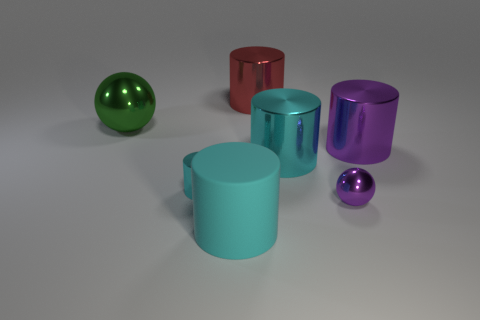Are any large yellow metal blocks visible?
Provide a succinct answer. No. Are there any large cylinders made of the same material as the green object?
Provide a succinct answer. Yes. Is there any other thing that has the same material as the tiny cyan object?
Ensure brevity in your answer.  Yes. What is the color of the tiny ball?
Your answer should be compact. Purple. What is the shape of the other big object that is the same color as the big rubber thing?
Provide a succinct answer. Cylinder. What is the color of the matte cylinder that is the same size as the red object?
Your answer should be very brief. Cyan. How many matte things are either purple things or small purple objects?
Your answer should be very brief. 0. What number of shiny cylinders are both on the left side of the large purple metal object and behind the tiny cyan object?
Keep it short and to the point. 2. How many other objects are the same size as the green metal object?
Your answer should be compact. 4. There is a cylinder that is to the right of the tiny purple thing; is its size the same as the metal ball that is to the right of the green metallic object?
Give a very brief answer. No. 